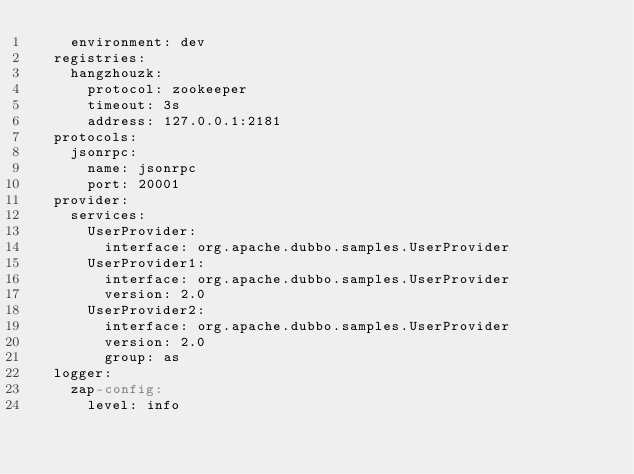Convert code to text. <code><loc_0><loc_0><loc_500><loc_500><_YAML_>    environment: dev
  registries:
    hangzhouzk:
      protocol: zookeeper
      timeout: 3s
      address: 127.0.0.1:2181
  protocols:
    jsonrpc:
      name: jsonrpc
      port: 20001
  provider:
    services:
      UserProvider:
        interface: org.apache.dubbo.samples.UserProvider
      UserProvider1:
        interface: org.apache.dubbo.samples.UserProvider
        version: 2.0
      UserProvider2:
        interface: org.apache.dubbo.samples.UserProvider
        version: 2.0
        group: as
  logger:
    zap-config:
      level: info</code> 